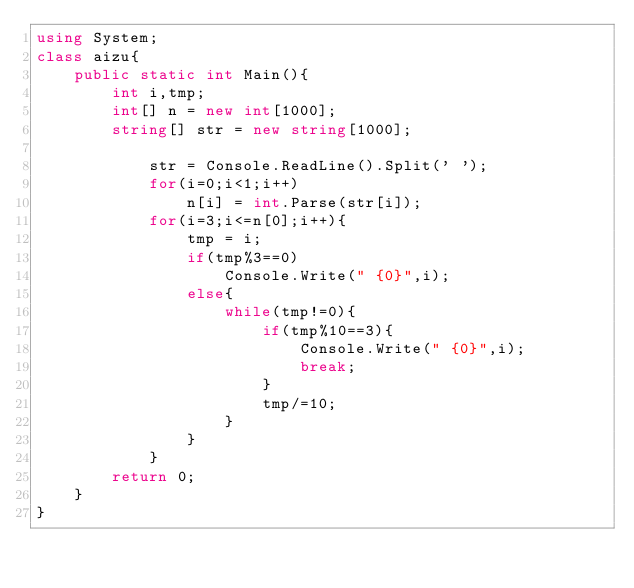Convert code to text. <code><loc_0><loc_0><loc_500><loc_500><_C#_>using System;
class aizu{
    public static int Main(){
        int i,tmp;
        int[] n = new int[1000];
        string[] str = new string[1000];

            str = Console.ReadLine().Split(' ');
            for(i=0;i<1;i++)
                n[i] = int.Parse(str[i]);
            for(i=3;i<=n[0];i++){
                tmp = i;
                if(tmp%3==0)
                    Console.Write(" {0}",i);
                else{
                    while(tmp!=0){
                        if(tmp%10==3){
                            Console.Write(" {0}",i);
                            break;
                        }
                        tmp/=10;
                    }
                }
            }        
        return 0;
    }  
}</code> 